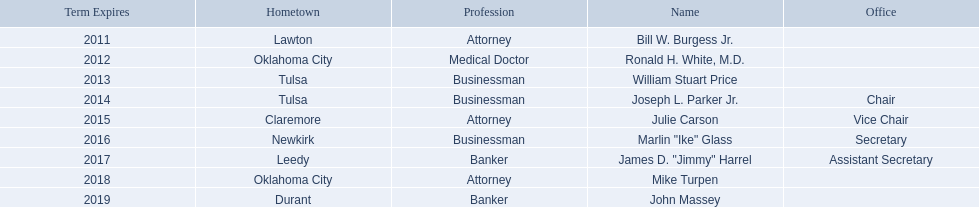What are all the names of oklahoma state regents for higher educations? Bill W. Burgess Jr., Ronald H. White, M.D., William Stuart Price, Joseph L. Parker Jr., Julie Carson, Marlin "Ike" Glass, James D. "Jimmy" Harrel, Mike Turpen, John Massey. Which ones are businessmen? William Stuart Price, Joseph L. Parker Jr., Marlin "Ike" Glass. Of those, who is from tulsa? William Stuart Price, Joseph L. Parker Jr. Whose term expires in 2014? Joseph L. Parker Jr. 